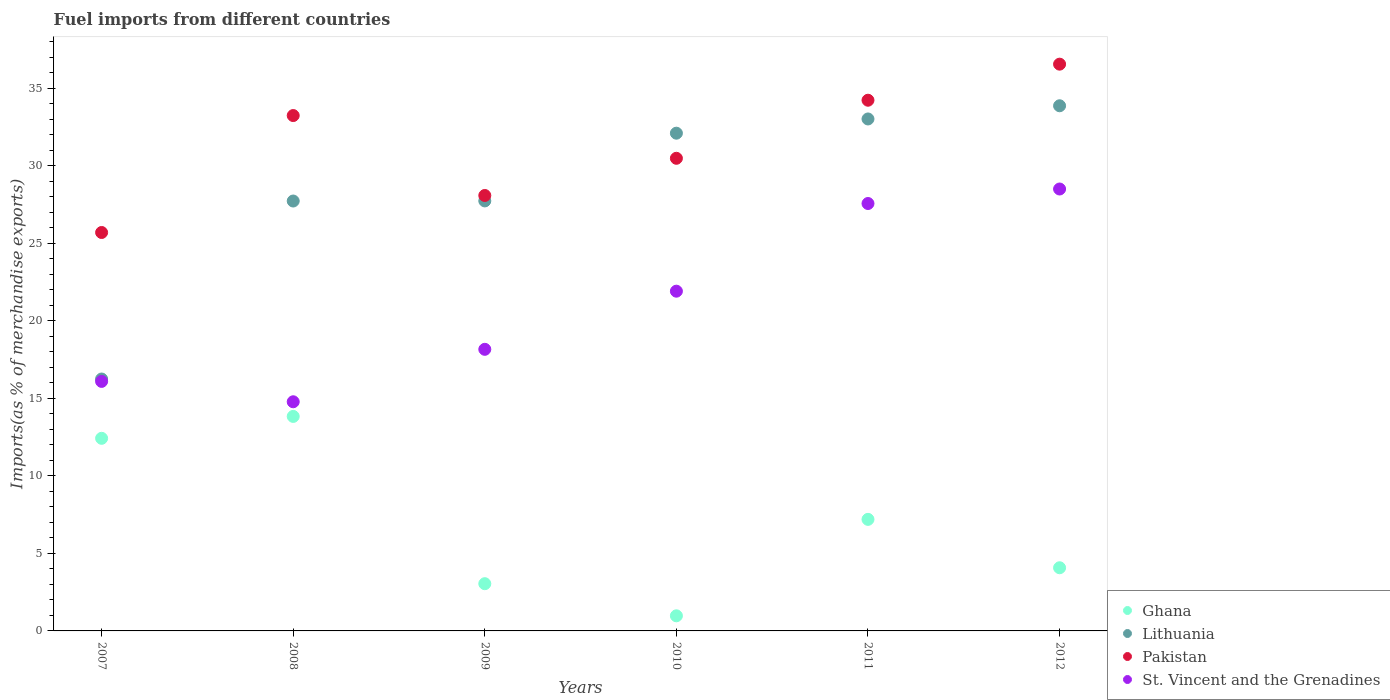How many different coloured dotlines are there?
Offer a very short reply. 4. What is the percentage of imports to different countries in St. Vincent and the Grenadines in 2011?
Provide a succinct answer. 27.57. Across all years, what is the maximum percentage of imports to different countries in Lithuania?
Give a very brief answer. 33.88. Across all years, what is the minimum percentage of imports to different countries in Pakistan?
Keep it short and to the point. 25.7. What is the total percentage of imports to different countries in Lithuania in the graph?
Ensure brevity in your answer.  170.74. What is the difference between the percentage of imports to different countries in St. Vincent and the Grenadines in 2009 and that in 2011?
Provide a succinct answer. -9.41. What is the difference between the percentage of imports to different countries in Pakistan in 2010 and the percentage of imports to different countries in Ghana in 2008?
Make the answer very short. 16.65. What is the average percentage of imports to different countries in Ghana per year?
Provide a short and direct response. 6.93. In the year 2012, what is the difference between the percentage of imports to different countries in Pakistan and percentage of imports to different countries in St. Vincent and the Grenadines?
Offer a very short reply. 8.05. What is the ratio of the percentage of imports to different countries in Ghana in 2009 to that in 2011?
Give a very brief answer. 0.42. Is the percentage of imports to different countries in Ghana in 2007 less than that in 2011?
Provide a succinct answer. No. Is the difference between the percentage of imports to different countries in Pakistan in 2008 and 2012 greater than the difference between the percentage of imports to different countries in St. Vincent and the Grenadines in 2008 and 2012?
Your response must be concise. Yes. What is the difference between the highest and the second highest percentage of imports to different countries in Lithuania?
Keep it short and to the point. 0.85. What is the difference between the highest and the lowest percentage of imports to different countries in Ghana?
Offer a terse response. 12.86. Is it the case that in every year, the sum of the percentage of imports to different countries in St. Vincent and the Grenadines and percentage of imports to different countries in Pakistan  is greater than the percentage of imports to different countries in Ghana?
Give a very brief answer. Yes. How many years are there in the graph?
Provide a short and direct response. 6. What is the difference between two consecutive major ticks on the Y-axis?
Offer a very short reply. 5. Are the values on the major ticks of Y-axis written in scientific E-notation?
Your response must be concise. No. Does the graph contain any zero values?
Your answer should be compact. No. Does the graph contain grids?
Make the answer very short. No. Where does the legend appear in the graph?
Your answer should be very brief. Bottom right. How are the legend labels stacked?
Give a very brief answer. Vertical. What is the title of the graph?
Keep it short and to the point. Fuel imports from different countries. What is the label or title of the Y-axis?
Ensure brevity in your answer.  Imports(as % of merchandise exports). What is the Imports(as % of merchandise exports) in Ghana in 2007?
Offer a very short reply. 12.43. What is the Imports(as % of merchandise exports) in Lithuania in 2007?
Give a very brief answer. 16.25. What is the Imports(as % of merchandise exports) in Pakistan in 2007?
Give a very brief answer. 25.7. What is the Imports(as % of merchandise exports) in St. Vincent and the Grenadines in 2007?
Make the answer very short. 16.1. What is the Imports(as % of merchandise exports) of Ghana in 2008?
Your response must be concise. 13.84. What is the Imports(as % of merchandise exports) in Lithuania in 2008?
Your answer should be very brief. 27.73. What is the Imports(as % of merchandise exports) in Pakistan in 2008?
Provide a short and direct response. 33.25. What is the Imports(as % of merchandise exports) of St. Vincent and the Grenadines in 2008?
Ensure brevity in your answer.  14.78. What is the Imports(as % of merchandise exports) in Ghana in 2009?
Offer a terse response. 3.05. What is the Imports(as % of merchandise exports) in Lithuania in 2009?
Ensure brevity in your answer.  27.74. What is the Imports(as % of merchandise exports) of Pakistan in 2009?
Make the answer very short. 28.09. What is the Imports(as % of merchandise exports) of St. Vincent and the Grenadines in 2009?
Give a very brief answer. 18.17. What is the Imports(as % of merchandise exports) in Ghana in 2010?
Keep it short and to the point. 0.97. What is the Imports(as % of merchandise exports) in Lithuania in 2010?
Keep it short and to the point. 32.11. What is the Imports(as % of merchandise exports) in Pakistan in 2010?
Give a very brief answer. 30.49. What is the Imports(as % of merchandise exports) of St. Vincent and the Grenadines in 2010?
Provide a short and direct response. 21.92. What is the Imports(as % of merchandise exports) of Ghana in 2011?
Make the answer very short. 7.2. What is the Imports(as % of merchandise exports) in Lithuania in 2011?
Provide a short and direct response. 33.03. What is the Imports(as % of merchandise exports) in Pakistan in 2011?
Provide a succinct answer. 34.24. What is the Imports(as % of merchandise exports) of St. Vincent and the Grenadines in 2011?
Your answer should be very brief. 27.57. What is the Imports(as % of merchandise exports) in Ghana in 2012?
Your response must be concise. 4.07. What is the Imports(as % of merchandise exports) in Lithuania in 2012?
Provide a succinct answer. 33.88. What is the Imports(as % of merchandise exports) in Pakistan in 2012?
Your answer should be compact. 36.56. What is the Imports(as % of merchandise exports) of St. Vincent and the Grenadines in 2012?
Your answer should be very brief. 28.51. Across all years, what is the maximum Imports(as % of merchandise exports) of Ghana?
Your answer should be compact. 13.84. Across all years, what is the maximum Imports(as % of merchandise exports) in Lithuania?
Keep it short and to the point. 33.88. Across all years, what is the maximum Imports(as % of merchandise exports) in Pakistan?
Offer a very short reply. 36.56. Across all years, what is the maximum Imports(as % of merchandise exports) of St. Vincent and the Grenadines?
Your answer should be compact. 28.51. Across all years, what is the minimum Imports(as % of merchandise exports) in Ghana?
Offer a terse response. 0.97. Across all years, what is the minimum Imports(as % of merchandise exports) in Lithuania?
Make the answer very short. 16.25. Across all years, what is the minimum Imports(as % of merchandise exports) of Pakistan?
Your response must be concise. 25.7. Across all years, what is the minimum Imports(as % of merchandise exports) in St. Vincent and the Grenadines?
Provide a short and direct response. 14.78. What is the total Imports(as % of merchandise exports) of Ghana in the graph?
Provide a succinct answer. 41.56. What is the total Imports(as % of merchandise exports) in Lithuania in the graph?
Ensure brevity in your answer.  170.74. What is the total Imports(as % of merchandise exports) of Pakistan in the graph?
Your answer should be compact. 188.33. What is the total Imports(as % of merchandise exports) in St. Vincent and the Grenadines in the graph?
Provide a succinct answer. 127.04. What is the difference between the Imports(as % of merchandise exports) of Ghana in 2007 and that in 2008?
Offer a terse response. -1.41. What is the difference between the Imports(as % of merchandise exports) of Lithuania in 2007 and that in 2008?
Make the answer very short. -11.48. What is the difference between the Imports(as % of merchandise exports) of Pakistan in 2007 and that in 2008?
Your response must be concise. -7.54. What is the difference between the Imports(as % of merchandise exports) of St. Vincent and the Grenadines in 2007 and that in 2008?
Provide a succinct answer. 1.31. What is the difference between the Imports(as % of merchandise exports) in Ghana in 2007 and that in 2009?
Give a very brief answer. 9.38. What is the difference between the Imports(as % of merchandise exports) in Lithuania in 2007 and that in 2009?
Keep it short and to the point. -11.49. What is the difference between the Imports(as % of merchandise exports) of Pakistan in 2007 and that in 2009?
Your answer should be very brief. -2.39. What is the difference between the Imports(as % of merchandise exports) in St. Vincent and the Grenadines in 2007 and that in 2009?
Offer a very short reply. -2.07. What is the difference between the Imports(as % of merchandise exports) in Ghana in 2007 and that in 2010?
Your answer should be very brief. 11.45. What is the difference between the Imports(as % of merchandise exports) in Lithuania in 2007 and that in 2010?
Provide a succinct answer. -15.86. What is the difference between the Imports(as % of merchandise exports) of Pakistan in 2007 and that in 2010?
Give a very brief answer. -4.79. What is the difference between the Imports(as % of merchandise exports) of St. Vincent and the Grenadines in 2007 and that in 2010?
Your answer should be compact. -5.82. What is the difference between the Imports(as % of merchandise exports) of Ghana in 2007 and that in 2011?
Keep it short and to the point. 5.23. What is the difference between the Imports(as % of merchandise exports) in Lithuania in 2007 and that in 2011?
Keep it short and to the point. -16.78. What is the difference between the Imports(as % of merchandise exports) in Pakistan in 2007 and that in 2011?
Give a very brief answer. -8.53. What is the difference between the Imports(as % of merchandise exports) in St. Vincent and the Grenadines in 2007 and that in 2011?
Offer a very short reply. -11.48. What is the difference between the Imports(as % of merchandise exports) of Ghana in 2007 and that in 2012?
Your answer should be compact. 8.35. What is the difference between the Imports(as % of merchandise exports) in Lithuania in 2007 and that in 2012?
Make the answer very short. -17.63. What is the difference between the Imports(as % of merchandise exports) of Pakistan in 2007 and that in 2012?
Make the answer very short. -10.86. What is the difference between the Imports(as % of merchandise exports) in St. Vincent and the Grenadines in 2007 and that in 2012?
Your answer should be compact. -12.41. What is the difference between the Imports(as % of merchandise exports) of Ghana in 2008 and that in 2009?
Provide a short and direct response. 10.79. What is the difference between the Imports(as % of merchandise exports) of Lithuania in 2008 and that in 2009?
Offer a very short reply. -0.01. What is the difference between the Imports(as % of merchandise exports) of Pakistan in 2008 and that in 2009?
Give a very brief answer. 5.16. What is the difference between the Imports(as % of merchandise exports) in St. Vincent and the Grenadines in 2008 and that in 2009?
Keep it short and to the point. -3.38. What is the difference between the Imports(as % of merchandise exports) of Ghana in 2008 and that in 2010?
Your response must be concise. 12.86. What is the difference between the Imports(as % of merchandise exports) of Lithuania in 2008 and that in 2010?
Give a very brief answer. -4.38. What is the difference between the Imports(as % of merchandise exports) in Pakistan in 2008 and that in 2010?
Provide a succinct answer. 2.76. What is the difference between the Imports(as % of merchandise exports) of St. Vincent and the Grenadines in 2008 and that in 2010?
Make the answer very short. -7.13. What is the difference between the Imports(as % of merchandise exports) in Ghana in 2008 and that in 2011?
Make the answer very short. 6.64. What is the difference between the Imports(as % of merchandise exports) of Lithuania in 2008 and that in 2011?
Your answer should be compact. -5.29. What is the difference between the Imports(as % of merchandise exports) in Pakistan in 2008 and that in 2011?
Your response must be concise. -0.99. What is the difference between the Imports(as % of merchandise exports) of St. Vincent and the Grenadines in 2008 and that in 2011?
Offer a terse response. -12.79. What is the difference between the Imports(as % of merchandise exports) of Ghana in 2008 and that in 2012?
Offer a very short reply. 9.76. What is the difference between the Imports(as % of merchandise exports) of Lithuania in 2008 and that in 2012?
Your answer should be compact. -6.14. What is the difference between the Imports(as % of merchandise exports) in Pakistan in 2008 and that in 2012?
Provide a succinct answer. -3.32. What is the difference between the Imports(as % of merchandise exports) in St. Vincent and the Grenadines in 2008 and that in 2012?
Your response must be concise. -13.73. What is the difference between the Imports(as % of merchandise exports) of Ghana in 2009 and that in 2010?
Provide a succinct answer. 2.07. What is the difference between the Imports(as % of merchandise exports) of Lithuania in 2009 and that in 2010?
Your answer should be compact. -4.37. What is the difference between the Imports(as % of merchandise exports) of Pakistan in 2009 and that in 2010?
Your answer should be very brief. -2.4. What is the difference between the Imports(as % of merchandise exports) of St. Vincent and the Grenadines in 2009 and that in 2010?
Give a very brief answer. -3.75. What is the difference between the Imports(as % of merchandise exports) in Ghana in 2009 and that in 2011?
Give a very brief answer. -4.15. What is the difference between the Imports(as % of merchandise exports) of Lithuania in 2009 and that in 2011?
Your answer should be very brief. -5.29. What is the difference between the Imports(as % of merchandise exports) in Pakistan in 2009 and that in 2011?
Provide a short and direct response. -6.15. What is the difference between the Imports(as % of merchandise exports) in St. Vincent and the Grenadines in 2009 and that in 2011?
Ensure brevity in your answer.  -9.41. What is the difference between the Imports(as % of merchandise exports) in Ghana in 2009 and that in 2012?
Offer a terse response. -1.03. What is the difference between the Imports(as % of merchandise exports) of Lithuania in 2009 and that in 2012?
Offer a very short reply. -6.14. What is the difference between the Imports(as % of merchandise exports) in Pakistan in 2009 and that in 2012?
Your answer should be compact. -8.47. What is the difference between the Imports(as % of merchandise exports) of St. Vincent and the Grenadines in 2009 and that in 2012?
Provide a short and direct response. -10.34. What is the difference between the Imports(as % of merchandise exports) in Ghana in 2010 and that in 2011?
Your answer should be compact. -6.22. What is the difference between the Imports(as % of merchandise exports) of Lithuania in 2010 and that in 2011?
Your response must be concise. -0.92. What is the difference between the Imports(as % of merchandise exports) in Pakistan in 2010 and that in 2011?
Provide a succinct answer. -3.75. What is the difference between the Imports(as % of merchandise exports) of St. Vincent and the Grenadines in 2010 and that in 2011?
Make the answer very short. -5.66. What is the difference between the Imports(as % of merchandise exports) of Ghana in 2010 and that in 2012?
Provide a short and direct response. -3.1. What is the difference between the Imports(as % of merchandise exports) in Lithuania in 2010 and that in 2012?
Offer a terse response. -1.77. What is the difference between the Imports(as % of merchandise exports) in Pakistan in 2010 and that in 2012?
Ensure brevity in your answer.  -6.07. What is the difference between the Imports(as % of merchandise exports) in St. Vincent and the Grenadines in 2010 and that in 2012?
Ensure brevity in your answer.  -6.59. What is the difference between the Imports(as % of merchandise exports) in Ghana in 2011 and that in 2012?
Offer a terse response. 3.12. What is the difference between the Imports(as % of merchandise exports) of Lithuania in 2011 and that in 2012?
Provide a succinct answer. -0.85. What is the difference between the Imports(as % of merchandise exports) of Pakistan in 2011 and that in 2012?
Offer a very short reply. -2.33. What is the difference between the Imports(as % of merchandise exports) of St. Vincent and the Grenadines in 2011 and that in 2012?
Your answer should be compact. -0.94. What is the difference between the Imports(as % of merchandise exports) in Ghana in 2007 and the Imports(as % of merchandise exports) in Lithuania in 2008?
Keep it short and to the point. -15.31. What is the difference between the Imports(as % of merchandise exports) in Ghana in 2007 and the Imports(as % of merchandise exports) in Pakistan in 2008?
Ensure brevity in your answer.  -20.82. What is the difference between the Imports(as % of merchandise exports) of Ghana in 2007 and the Imports(as % of merchandise exports) of St. Vincent and the Grenadines in 2008?
Your response must be concise. -2.36. What is the difference between the Imports(as % of merchandise exports) of Lithuania in 2007 and the Imports(as % of merchandise exports) of Pakistan in 2008?
Your response must be concise. -17. What is the difference between the Imports(as % of merchandise exports) in Lithuania in 2007 and the Imports(as % of merchandise exports) in St. Vincent and the Grenadines in 2008?
Ensure brevity in your answer.  1.47. What is the difference between the Imports(as % of merchandise exports) of Pakistan in 2007 and the Imports(as % of merchandise exports) of St. Vincent and the Grenadines in 2008?
Make the answer very short. 10.92. What is the difference between the Imports(as % of merchandise exports) of Ghana in 2007 and the Imports(as % of merchandise exports) of Lithuania in 2009?
Your answer should be compact. -15.32. What is the difference between the Imports(as % of merchandise exports) in Ghana in 2007 and the Imports(as % of merchandise exports) in Pakistan in 2009?
Your response must be concise. -15.67. What is the difference between the Imports(as % of merchandise exports) of Ghana in 2007 and the Imports(as % of merchandise exports) of St. Vincent and the Grenadines in 2009?
Make the answer very short. -5.74. What is the difference between the Imports(as % of merchandise exports) of Lithuania in 2007 and the Imports(as % of merchandise exports) of Pakistan in 2009?
Your response must be concise. -11.84. What is the difference between the Imports(as % of merchandise exports) of Lithuania in 2007 and the Imports(as % of merchandise exports) of St. Vincent and the Grenadines in 2009?
Your response must be concise. -1.92. What is the difference between the Imports(as % of merchandise exports) of Pakistan in 2007 and the Imports(as % of merchandise exports) of St. Vincent and the Grenadines in 2009?
Your answer should be compact. 7.54. What is the difference between the Imports(as % of merchandise exports) in Ghana in 2007 and the Imports(as % of merchandise exports) in Lithuania in 2010?
Your answer should be very brief. -19.68. What is the difference between the Imports(as % of merchandise exports) of Ghana in 2007 and the Imports(as % of merchandise exports) of Pakistan in 2010?
Your answer should be compact. -18.06. What is the difference between the Imports(as % of merchandise exports) in Ghana in 2007 and the Imports(as % of merchandise exports) in St. Vincent and the Grenadines in 2010?
Your answer should be very brief. -9.49. What is the difference between the Imports(as % of merchandise exports) in Lithuania in 2007 and the Imports(as % of merchandise exports) in Pakistan in 2010?
Make the answer very short. -14.24. What is the difference between the Imports(as % of merchandise exports) in Lithuania in 2007 and the Imports(as % of merchandise exports) in St. Vincent and the Grenadines in 2010?
Offer a very short reply. -5.67. What is the difference between the Imports(as % of merchandise exports) of Pakistan in 2007 and the Imports(as % of merchandise exports) of St. Vincent and the Grenadines in 2010?
Give a very brief answer. 3.79. What is the difference between the Imports(as % of merchandise exports) in Ghana in 2007 and the Imports(as % of merchandise exports) in Lithuania in 2011?
Your response must be concise. -20.6. What is the difference between the Imports(as % of merchandise exports) of Ghana in 2007 and the Imports(as % of merchandise exports) of Pakistan in 2011?
Offer a very short reply. -21.81. What is the difference between the Imports(as % of merchandise exports) in Ghana in 2007 and the Imports(as % of merchandise exports) in St. Vincent and the Grenadines in 2011?
Offer a very short reply. -15.15. What is the difference between the Imports(as % of merchandise exports) of Lithuania in 2007 and the Imports(as % of merchandise exports) of Pakistan in 2011?
Your answer should be very brief. -17.98. What is the difference between the Imports(as % of merchandise exports) of Lithuania in 2007 and the Imports(as % of merchandise exports) of St. Vincent and the Grenadines in 2011?
Your answer should be compact. -11.32. What is the difference between the Imports(as % of merchandise exports) in Pakistan in 2007 and the Imports(as % of merchandise exports) in St. Vincent and the Grenadines in 2011?
Ensure brevity in your answer.  -1.87. What is the difference between the Imports(as % of merchandise exports) of Ghana in 2007 and the Imports(as % of merchandise exports) of Lithuania in 2012?
Your answer should be compact. -21.45. What is the difference between the Imports(as % of merchandise exports) in Ghana in 2007 and the Imports(as % of merchandise exports) in Pakistan in 2012?
Ensure brevity in your answer.  -24.14. What is the difference between the Imports(as % of merchandise exports) in Ghana in 2007 and the Imports(as % of merchandise exports) in St. Vincent and the Grenadines in 2012?
Your response must be concise. -16.08. What is the difference between the Imports(as % of merchandise exports) in Lithuania in 2007 and the Imports(as % of merchandise exports) in Pakistan in 2012?
Give a very brief answer. -20.31. What is the difference between the Imports(as % of merchandise exports) in Lithuania in 2007 and the Imports(as % of merchandise exports) in St. Vincent and the Grenadines in 2012?
Your response must be concise. -12.26. What is the difference between the Imports(as % of merchandise exports) in Pakistan in 2007 and the Imports(as % of merchandise exports) in St. Vincent and the Grenadines in 2012?
Make the answer very short. -2.81. What is the difference between the Imports(as % of merchandise exports) in Ghana in 2008 and the Imports(as % of merchandise exports) in Lithuania in 2009?
Keep it short and to the point. -13.9. What is the difference between the Imports(as % of merchandise exports) in Ghana in 2008 and the Imports(as % of merchandise exports) in Pakistan in 2009?
Your response must be concise. -14.25. What is the difference between the Imports(as % of merchandise exports) of Ghana in 2008 and the Imports(as % of merchandise exports) of St. Vincent and the Grenadines in 2009?
Your answer should be compact. -4.33. What is the difference between the Imports(as % of merchandise exports) in Lithuania in 2008 and the Imports(as % of merchandise exports) in Pakistan in 2009?
Give a very brief answer. -0.36. What is the difference between the Imports(as % of merchandise exports) of Lithuania in 2008 and the Imports(as % of merchandise exports) of St. Vincent and the Grenadines in 2009?
Ensure brevity in your answer.  9.57. What is the difference between the Imports(as % of merchandise exports) in Pakistan in 2008 and the Imports(as % of merchandise exports) in St. Vincent and the Grenadines in 2009?
Offer a very short reply. 15.08. What is the difference between the Imports(as % of merchandise exports) in Ghana in 2008 and the Imports(as % of merchandise exports) in Lithuania in 2010?
Offer a terse response. -18.27. What is the difference between the Imports(as % of merchandise exports) of Ghana in 2008 and the Imports(as % of merchandise exports) of Pakistan in 2010?
Your answer should be very brief. -16.65. What is the difference between the Imports(as % of merchandise exports) in Ghana in 2008 and the Imports(as % of merchandise exports) in St. Vincent and the Grenadines in 2010?
Offer a terse response. -8.08. What is the difference between the Imports(as % of merchandise exports) in Lithuania in 2008 and the Imports(as % of merchandise exports) in Pakistan in 2010?
Provide a succinct answer. -2.76. What is the difference between the Imports(as % of merchandise exports) in Lithuania in 2008 and the Imports(as % of merchandise exports) in St. Vincent and the Grenadines in 2010?
Provide a short and direct response. 5.82. What is the difference between the Imports(as % of merchandise exports) in Pakistan in 2008 and the Imports(as % of merchandise exports) in St. Vincent and the Grenadines in 2010?
Ensure brevity in your answer.  11.33. What is the difference between the Imports(as % of merchandise exports) of Ghana in 2008 and the Imports(as % of merchandise exports) of Lithuania in 2011?
Your answer should be compact. -19.19. What is the difference between the Imports(as % of merchandise exports) of Ghana in 2008 and the Imports(as % of merchandise exports) of Pakistan in 2011?
Provide a short and direct response. -20.4. What is the difference between the Imports(as % of merchandise exports) in Ghana in 2008 and the Imports(as % of merchandise exports) in St. Vincent and the Grenadines in 2011?
Ensure brevity in your answer.  -13.73. What is the difference between the Imports(as % of merchandise exports) of Lithuania in 2008 and the Imports(as % of merchandise exports) of Pakistan in 2011?
Keep it short and to the point. -6.5. What is the difference between the Imports(as % of merchandise exports) in Lithuania in 2008 and the Imports(as % of merchandise exports) in St. Vincent and the Grenadines in 2011?
Offer a very short reply. 0.16. What is the difference between the Imports(as % of merchandise exports) in Pakistan in 2008 and the Imports(as % of merchandise exports) in St. Vincent and the Grenadines in 2011?
Your response must be concise. 5.67. What is the difference between the Imports(as % of merchandise exports) of Ghana in 2008 and the Imports(as % of merchandise exports) of Lithuania in 2012?
Your answer should be very brief. -20.04. What is the difference between the Imports(as % of merchandise exports) of Ghana in 2008 and the Imports(as % of merchandise exports) of Pakistan in 2012?
Give a very brief answer. -22.72. What is the difference between the Imports(as % of merchandise exports) in Ghana in 2008 and the Imports(as % of merchandise exports) in St. Vincent and the Grenadines in 2012?
Provide a succinct answer. -14.67. What is the difference between the Imports(as % of merchandise exports) in Lithuania in 2008 and the Imports(as % of merchandise exports) in Pakistan in 2012?
Your response must be concise. -8.83. What is the difference between the Imports(as % of merchandise exports) of Lithuania in 2008 and the Imports(as % of merchandise exports) of St. Vincent and the Grenadines in 2012?
Offer a terse response. -0.78. What is the difference between the Imports(as % of merchandise exports) in Pakistan in 2008 and the Imports(as % of merchandise exports) in St. Vincent and the Grenadines in 2012?
Keep it short and to the point. 4.74. What is the difference between the Imports(as % of merchandise exports) in Ghana in 2009 and the Imports(as % of merchandise exports) in Lithuania in 2010?
Offer a terse response. -29.06. What is the difference between the Imports(as % of merchandise exports) of Ghana in 2009 and the Imports(as % of merchandise exports) of Pakistan in 2010?
Offer a very short reply. -27.44. What is the difference between the Imports(as % of merchandise exports) in Ghana in 2009 and the Imports(as % of merchandise exports) in St. Vincent and the Grenadines in 2010?
Offer a very short reply. -18.87. What is the difference between the Imports(as % of merchandise exports) of Lithuania in 2009 and the Imports(as % of merchandise exports) of Pakistan in 2010?
Ensure brevity in your answer.  -2.75. What is the difference between the Imports(as % of merchandise exports) in Lithuania in 2009 and the Imports(as % of merchandise exports) in St. Vincent and the Grenadines in 2010?
Provide a succinct answer. 5.82. What is the difference between the Imports(as % of merchandise exports) of Pakistan in 2009 and the Imports(as % of merchandise exports) of St. Vincent and the Grenadines in 2010?
Make the answer very short. 6.17. What is the difference between the Imports(as % of merchandise exports) in Ghana in 2009 and the Imports(as % of merchandise exports) in Lithuania in 2011?
Give a very brief answer. -29.98. What is the difference between the Imports(as % of merchandise exports) of Ghana in 2009 and the Imports(as % of merchandise exports) of Pakistan in 2011?
Offer a terse response. -31.19. What is the difference between the Imports(as % of merchandise exports) in Ghana in 2009 and the Imports(as % of merchandise exports) in St. Vincent and the Grenadines in 2011?
Keep it short and to the point. -24.53. What is the difference between the Imports(as % of merchandise exports) of Lithuania in 2009 and the Imports(as % of merchandise exports) of Pakistan in 2011?
Offer a very short reply. -6.5. What is the difference between the Imports(as % of merchandise exports) in Lithuania in 2009 and the Imports(as % of merchandise exports) in St. Vincent and the Grenadines in 2011?
Make the answer very short. 0.17. What is the difference between the Imports(as % of merchandise exports) in Pakistan in 2009 and the Imports(as % of merchandise exports) in St. Vincent and the Grenadines in 2011?
Your response must be concise. 0.52. What is the difference between the Imports(as % of merchandise exports) in Ghana in 2009 and the Imports(as % of merchandise exports) in Lithuania in 2012?
Make the answer very short. -30.83. What is the difference between the Imports(as % of merchandise exports) of Ghana in 2009 and the Imports(as % of merchandise exports) of Pakistan in 2012?
Provide a succinct answer. -33.52. What is the difference between the Imports(as % of merchandise exports) in Ghana in 2009 and the Imports(as % of merchandise exports) in St. Vincent and the Grenadines in 2012?
Give a very brief answer. -25.46. What is the difference between the Imports(as % of merchandise exports) of Lithuania in 2009 and the Imports(as % of merchandise exports) of Pakistan in 2012?
Give a very brief answer. -8.82. What is the difference between the Imports(as % of merchandise exports) in Lithuania in 2009 and the Imports(as % of merchandise exports) in St. Vincent and the Grenadines in 2012?
Your answer should be very brief. -0.77. What is the difference between the Imports(as % of merchandise exports) of Pakistan in 2009 and the Imports(as % of merchandise exports) of St. Vincent and the Grenadines in 2012?
Your response must be concise. -0.42. What is the difference between the Imports(as % of merchandise exports) of Ghana in 2010 and the Imports(as % of merchandise exports) of Lithuania in 2011?
Offer a very short reply. -32.05. What is the difference between the Imports(as % of merchandise exports) of Ghana in 2010 and the Imports(as % of merchandise exports) of Pakistan in 2011?
Keep it short and to the point. -33.26. What is the difference between the Imports(as % of merchandise exports) of Ghana in 2010 and the Imports(as % of merchandise exports) of St. Vincent and the Grenadines in 2011?
Give a very brief answer. -26.6. What is the difference between the Imports(as % of merchandise exports) in Lithuania in 2010 and the Imports(as % of merchandise exports) in Pakistan in 2011?
Ensure brevity in your answer.  -2.13. What is the difference between the Imports(as % of merchandise exports) of Lithuania in 2010 and the Imports(as % of merchandise exports) of St. Vincent and the Grenadines in 2011?
Offer a very short reply. 4.54. What is the difference between the Imports(as % of merchandise exports) in Pakistan in 2010 and the Imports(as % of merchandise exports) in St. Vincent and the Grenadines in 2011?
Your answer should be compact. 2.92. What is the difference between the Imports(as % of merchandise exports) in Ghana in 2010 and the Imports(as % of merchandise exports) in Lithuania in 2012?
Offer a terse response. -32.9. What is the difference between the Imports(as % of merchandise exports) of Ghana in 2010 and the Imports(as % of merchandise exports) of Pakistan in 2012?
Your answer should be very brief. -35.59. What is the difference between the Imports(as % of merchandise exports) in Ghana in 2010 and the Imports(as % of merchandise exports) in St. Vincent and the Grenadines in 2012?
Offer a very short reply. -27.53. What is the difference between the Imports(as % of merchandise exports) in Lithuania in 2010 and the Imports(as % of merchandise exports) in Pakistan in 2012?
Offer a terse response. -4.45. What is the difference between the Imports(as % of merchandise exports) in Lithuania in 2010 and the Imports(as % of merchandise exports) in St. Vincent and the Grenadines in 2012?
Your answer should be compact. 3.6. What is the difference between the Imports(as % of merchandise exports) in Pakistan in 2010 and the Imports(as % of merchandise exports) in St. Vincent and the Grenadines in 2012?
Give a very brief answer. 1.98. What is the difference between the Imports(as % of merchandise exports) in Ghana in 2011 and the Imports(as % of merchandise exports) in Lithuania in 2012?
Offer a terse response. -26.68. What is the difference between the Imports(as % of merchandise exports) of Ghana in 2011 and the Imports(as % of merchandise exports) of Pakistan in 2012?
Your answer should be very brief. -29.37. What is the difference between the Imports(as % of merchandise exports) of Ghana in 2011 and the Imports(as % of merchandise exports) of St. Vincent and the Grenadines in 2012?
Offer a terse response. -21.31. What is the difference between the Imports(as % of merchandise exports) of Lithuania in 2011 and the Imports(as % of merchandise exports) of Pakistan in 2012?
Offer a very short reply. -3.54. What is the difference between the Imports(as % of merchandise exports) of Lithuania in 2011 and the Imports(as % of merchandise exports) of St. Vincent and the Grenadines in 2012?
Provide a succinct answer. 4.52. What is the difference between the Imports(as % of merchandise exports) of Pakistan in 2011 and the Imports(as % of merchandise exports) of St. Vincent and the Grenadines in 2012?
Offer a terse response. 5.73. What is the average Imports(as % of merchandise exports) in Ghana per year?
Offer a very short reply. 6.93. What is the average Imports(as % of merchandise exports) in Lithuania per year?
Ensure brevity in your answer.  28.46. What is the average Imports(as % of merchandise exports) in Pakistan per year?
Keep it short and to the point. 31.39. What is the average Imports(as % of merchandise exports) in St. Vincent and the Grenadines per year?
Keep it short and to the point. 21.17. In the year 2007, what is the difference between the Imports(as % of merchandise exports) in Ghana and Imports(as % of merchandise exports) in Lithuania?
Keep it short and to the point. -3.83. In the year 2007, what is the difference between the Imports(as % of merchandise exports) of Ghana and Imports(as % of merchandise exports) of Pakistan?
Keep it short and to the point. -13.28. In the year 2007, what is the difference between the Imports(as % of merchandise exports) of Ghana and Imports(as % of merchandise exports) of St. Vincent and the Grenadines?
Offer a terse response. -3.67. In the year 2007, what is the difference between the Imports(as % of merchandise exports) of Lithuania and Imports(as % of merchandise exports) of Pakistan?
Provide a short and direct response. -9.45. In the year 2007, what is the difference between the Imports(as % of merchandise exports) in Lithuania and Imports(as % of merchandise exports) in St. Vincent and the Grenadines?
Provide a succinct answer. 0.15. In the year 2007, what is the difference between the Imports(as % of merchandise exports) in Pakistan and Imports(as % of merchandise exports) in St. Vincent and the Grenadines?
Keep it short and to the point. 9.61. In the year 2008, what is the difference between the Imports(as % of merchandise exports) of Ghana and Imports(as % of merchandise exports) of Lithuania?
Make the answer very short. -13.9. In the year 2008, what is the difference between the Imports(as % of merchandise exports) of Ghana and Imports(as % of merchandise exports) of Pakistan?
Ensure brevity in your answer.  -19.41. In the year 2008, what is the difference between the Imports(as % of merchandise exports) of Ghana and Imports(as % of merchandise exports) of St. Vincent and the Grenadines?
Offer a very short reply. -0.95. In the year 2008, what is the difference between the Imports(as % of merchandise exports) in Lithuania and Imports(as % of merchandise exports) in Pakistan?
Provide a succinct answer. -5.51. In the year 2008, what is the difference between the Imports(as % of merchandise exports) in Lithuania and Imports(as % of merchandise exports) in St. Vincent and the Grenadines?
Give a very brief answer. 12.95. In the year 2008, what is the difference between the Imports(as % of merchandise exports) in Pakistan and Imports(as % of merchandise exports) in St. Vincent and the Grenadines?
Your response must be concise. 18.46. In the year 2009, what is the difference between the Imports(as % of merchandise exports) of Ghana and Imports(as % of merchandise exports) of Lithuania?
Your response must be concise. -24.69. In the year 2009, what is the difference between the Imports(as % of merchandise exports) in Ghana and Imports(as % of merchandise exports) in Pakistan?
Provide a short and direct response. -25.04. In the year 2009, what is the difference between the Imports(as % of merchandise exports) in Ghana and Imports(as % of merchandise exports) in St. Vincent and the Grenadines?
Offer a very short reply. -15.12. In the year 2009, what is the difference between the Imports(as % of merchandise exports) of Lithuania and Imports(as % of merchandise exports) of Pakistan?
Your answer should be very brief. -0.35. In the year 2009, what is the difference between the Imports(as % of merchandise exports) of Lithuania and Imports(as % of merchandise exports) of St. Vincent and the Grenadines?
Make the answer very short. 9.57. In the year 2009, what is the difference between the Imports(as % of merchandise exports) in Pakistan and Imports(as % of merchandise exports) in St. Vincent and the Grenadines?
Keep it short and to the point. 9.92. In the year 2010, what is the difference between the Imports(as % of merchandise exports) of Ghana and Imports(as % of merchandise exports) of Lithuania?
Provide a short and direct response. -31.13. In the year 2010, what is the difference between the Imports(as % of merchandise exports) of Ghana and Imports(as % of merchandise exports) of Pakistan?
Offer a very short reply. -29.52. In the year 2010, what is the difference between the Imports(as % of merchandise exports) of Ghana and Imports(as % of merchandise exports) of St. Vincent and the Grenadines?
Ensure brevity in your answer.  -20.94. In the year 2010, what is the difference between the Imports(as % of merchandise exports) of Lithuania and Imports(as % of merchandise exports) of Pakistan?
Provide a short and direct response. 1.62. In the year 2010, what is the difference between the Imports(as % of merchandise exports) of Lithuania and Imports(as % of merchandise exports) of St. Vincent and the Grenadines?
Your answer should be compact. 10.19. In the year 2010, what is the difference between the Imports(as % of merchandise exports) in Pakistan and Imports(as % of merchandise exports) in St. Vincent and the Grenadines?
Make the answer very short. 8.57. In the year 2011, what is the difference between the Imports(as % of merchandise exports) in Ghana and Imports(as % of merchandise exports) in Lithuania?
Keep it short and to the point. -25.83. In the year 2011, what is the difference between the Imports(as % of merchandise exports) of Ghana and Imports(as % of merchandise exports) of Pakistan?
Provide a short and direct response. -27.04. In the year 2011, what is the difference between the Imports(as % of merchandise exports) of Ghana and Imports(as % of merchandise exports) of St. Vincent and the Grenadines?
Provide a succinct answer. -20.38. In the year 2011, what is the difference between the Imports(as % of merchandise exports) of Lithuania and Imports(as % of merchandise exports) of Pakistan?
Provide a succinct answer. -1.21. In the year 2011, what is the difference between the Imports(as % of merchandise exports) of Lithuania and Imports(as % of merchandise exports) of St. Vincent and the Grenadines?
Provide a short and direct response. 5.45. In the year 2011, what is the difference between the Imports(as % of merchandise exports) of Pakistan and Imports(as % of merchandise exports) of St. Vincent and the Grenadines?
Your answer should be very brief. 6.66. In the year 2012, what is the difference between the Imports(as % of merchandise exports) of Ghana and Imports(as % of merchandise exports) of Lithuania?
Offer a terse response. -29.8. In the year 2012, what is the difference between the Imports(as % of merchandise exports) in Ghana and Imports(as % of merchandise exports) in Pakistan?
Offer a very short reply. -32.49. In the year 2012, what is the difference between the Imports(as % of merchandise exports) of Ghana and Imports(as % of merchandise exports) of St. Vincent and the Grenadines?
Make the answer very short. -24.43. In the year 2012, what is the difference between the Imports(as % of merchandise exports) in Lithuania and Imports(as % of merchandise exports) in Pakistan?
Your answer should be compact. -2.68. In the year 2012, what is the difference between the Imports(as % of merchandise exports) of Lithuania and Imports(as % of merchandise exports) of St. Vincent and the Grenadines?
Your answer should be compact. 5.37. In the year 2012, what is the difference between the Imports(as % of merchandise exports) in Pakistan and Imports(as % of merchandise exports) in St. Vincent and the Grenadines?
Keep it short and to the point. 8.05. What is the ratio of the Imports(as % of merchandise exports) of Ghana in 2007 to that in 2008?
Your answer should be very brief. 0.9. What is the ratio of the Imports(as % of merchandise exports) of Lithuania in 2007 to that in 2008?
Provide a succinct answer. 0.59. What is the ratio of the Imports(as % of merchandise exports) in Pakistan in 2007 to that in 2008?
Offer a very short reply. 0.77. What is the ratio of the Imports(as % of merchandise exports) of St. Vincent and the Grenadines in 2007 to that in 2008?
Your response must be concise. 1.09. What is the ratio of the Imports(as % of merchandise exports) of Ghana in 2007 to that in 2009?
Give a very brief answer. 4.08. What is the ratio of the Imports(as % of merchandise exports) in Lithuania in 2007 to that in 2009?
Offer a terse response. 0.59. What is the ratio of the Imports(as % of merchandise exports) of Pakistan in 2007 to that in 2009?
Your response must be concise. 0.92. What is the ratio of the Imports(as % of merchandise exports) of St. Vincent and the Grenadines in 2007 to that in 2009?
Ensure brevity in your answer.  0.89. What is the ratio of the Imports(as % of merchandise exports) of Ghana in 2007 to that in 2010?
Offer a very short reply. 12.75. What is the ratio of the Imports(as % of merchandise exports) in Lithuania in 2007 to that in 2010?
Offer a terse response. 0.51. What is the ratio of the Imports(as % of merchandise exports) in Pakistan in 2007 to that in 2010?
Keep it short and to the point. 0.84. What is the ratio of the Imports(as % of merchandise exports) in St. Vincent and the Grenadines in 2007 to that in 2010?
Your response must be concise. 0.73. What is the ratio of the Imports(as % of merchandise exports) of Ghana in 2007 to that in 2011?
Your answer should be very brief. 1.73. What is the ratio of the Imports(as % of merchandise exports) in Lithuania in 2007 to that in 2011?
Make the answer very short. 0.49. What is the ratio of the Imports(as % of merchandise exports) of Pakistan in 2007 to that in 2011?
Ensure brevity in your answer.  0.75. What is the ratio of the Imports(as % of merchandise exports) of St. Vincent and the Grenadines in 2007 to that in 2011?
Your response must be concise. 0.58. What is the ratio of the Imports(as % of merchandise exports) in Ghana in 2007 to that in 2012?
Give a very brief answer. 3.05. What is the ratio of the Imports(as % of merchandise exports) of Lithuania in 2007 to that in 2012?
Your answer should be very brief. 0.48. What is the ratio of the Imports(as % of merchandise exports) of Pakistan in 2007 to that in 2012?
Provide a succinct answer. 0.7. What is the ratio of the Imports(as % of merchandise exports) in St. Vincent and the Grenadines in 2007 to that in 2012?
Your response must be concise. 0.56. What is the ratio of the Imports(as % of merchandise exports) of Ghana in 2008 to that in 2009?
Give a very brief answer. 4.54. What is the ratio of the Imports(as % of merchandise exports) of Pakistan in 2008 to that in 2009?
Ensure brevity in your answer.  1.18. What is the ratio of the Imports(as % of merchandise exports) of St. Vincent and the Grenadines in 2008 to that in 2009?
Keep it short and to the point. 0.81. What is the ratio of the Imports(as % of merchandise exports) in Ghana in 2008 to that in 2010?
Offer a very short reply. 14.2. What is the ratio of the Imports(as % of merchandise exports) of Lithuania in 2008 to that in 2010?
Make the answer very short. 0.86. What is the ratio of the Imports(as % of merchandise exports) in Pakistan in 2008 to that in 2010?
Ensure brevity in your answer.  1.09. What is the ratio of the Imports(as % of merchandise exports) of St. Vincent and the Grenadines in 2008 to that in 2010?
Give a very brief answer. 0.67. What is the ratio of the Imports(as % of merchandise exports) in Ghana in 2008 to that in 2011?
Your answer should be compact. 1.92. What is the ratio of the Imports(as % of merchandise exports) of Lithuania in 2008 to that in 2011?
Give a very brief answer. 0.84. What is the ratio of the Imports(as % of merchandise exports) of Pakistan in 2008 to that in 2011?
Keep it short and to the point. 0.97. What is the ratio of the Imports(as % of merchandise exports) of St. Vincent and the Grenadines in 2008 to that in 2011?
Your answer should be compact. 0.54. What is the ratio of the Imports(as % of merchandise exports) in Ghana in 2008 to that in 2012?
Offer a terse response. 3.4. What is the ratio of the Imports(as % of merchandise exports) of Lithuania in 2008 to that in 2012?
Offer a very short reply. 0.82. What is the ratio of the Imports(as % of merchandise exports) of Pakistan in 2008 to that in 2012?
Your answer should be very brief. 0.91. What is the ratio of the Imports(as % of merchandise exports) in St. Vincent and the Grenadines in 2008 to that in 2012?
Give a very brief answer. 0.52. What is the ratio of the Imports(as % of merchandise exports) of Ghana in 2009 to that in 2010?
Offer a very short reply. 3.13. What is the ratio of the Imports(as % of merchandise exports) in Lithuania in 2009 to that in 2010?
Your answer should be compact. 0.86. What is the ratio of the Imports(as % of merchandise exports) in Pakistan in 2009 to that in 2010?
Your response must be concise. 0.92. What is the ratio of the Imports(as % of merchandise exports) in St. Vincent and the Grenadines in 2009 to that in 2010?
Provide a short and direct response. 0.83. What is the ratio of the Imports(as % of merchandise exports) in Ghana in 2009 to that in 2011?
Provide a succinct answer. 0.42. What is the ratio of the Imports(as % of merchandise exports) in Lithuania in 2009 to that in 2011?
Offer a very short reply. 0.84. What is the ratio of the Imports(as % of merchandise exports) of Pakistan in 2009 to that in 2011?
Offer a terse response. 0.82. What is the ratio of the Imports(as % of merchandise exports) of St. Vincent and the Grenadines in 2009 to that in 2011?
Offer a terse response. 0.66. What is the ratio of the Imports(as % of merchandise exports) of Ghana in 2009 to that in 2012?
Keep it short and to the point. 0.75. What is the ratio of the Imports(as % of merchandise exports) of Lithuania in 2009 to that in 2012?
Give a very brief answer. 0.82. What is the ratio of the Imports(as % of merchandise exports) in Pakistan in 2009 to that in 2012?
Provide a succinct answer. 0.77. What is the ratio of the Imports(as % of merchandise exports) in St. Vincent and the Grenadines in 2009 to that in 2012?
Your answer should be compact. 0.64. What is the ratio of the Imports(as % of merchandise exports) in Ghana in 2010 to that in 2011?
Give a very brief answer. 0.14. What is the ratio of the Imports(as % of merchandise exports) of Lithuania in 2010 to that in 2011?
Give a very brief answer. 0.97. What is the ratio of the Imports(as % of merchandise exports) in Pakistan in 2010 to that in 2011?
Make the answer very short. 0.89. What is the ratio of the Imports(as % of merchandise exports) in St. Vincent and the Grenadines in 2010 to that in 2011?
Your response must be concise. 0.79. What is the ratio of the Imports(as % of merchandise exports) of Ghana in 2010 to that in 2012?
Provide a short and direct response. 0.24. What is the ratio of the Imports(as % of merchandise exports) of Lithuania in 2010 to that in 2012?
Give a very brief answer. 0.95. What is the ratio of the Imports(as % of merchandise exports) in Pakistan in 2010 to that in 2012?
Provide a short and direct response. 0.83. What is the ratio of the Imports(as % of merchandise exports) in St. Vincent and the Grenadines in 2010 to that in 2012?
Your answer should be compact. 0.77. What is the ratio of the Imports(as % of merchandise exports) in Ghana in 2011 to that in 2012?
Keep it short and to the point. 1.77. What is the ratio of the Imports(as % of merchandise exports) of Lithuania in 2011 to that in 2012?
Your answer should be very brief. 0.97. What is the ratio of the Imports(as % of merchandise exports) in Pakistan in 2011 to that in 2012?
Provide a short and direct response. 0.94. What is the ratio of the Imports(as % of merchandise exports) in St. Vincent and the Grenadines in 2011 to that in 2012?
Make the answer very short. 0.97. What is the difference between the highest and the second highest Imports(as % of merchandise exports) in Ghana?
Ensure brevity in your answer.  1.41. What is the difference between the highest and the second highest Imports(as % of merchandise exports) in Lithuania?
Provide a short and direct response. 0.85. What is the difference between the highest and the second highest Imports(as % of merchandise exports) in Pakistan?
Offer a terse response. 2.33. What is the difference between the highest and the second highest Imports(as % of merchandise exports) in St. Vincent and the Grenadines?
Keep it short and to the point. 0.94. What is the difference between the highest and the lowest Imports(as % of merchandise exports) in Ghana?
Your answer should be very brief. 12.86. What is the difference between the highest and the lowest Imports(as % of merchandise exports) in Lithuania?
Ensure brevity in your answer.  17.63. What is the difference between the highest and the lowest Imports(as % of merchandise exports) in Pakistan?
Keep it short and to the point. 10.86. What is the difference between the highest and the lowest Imports(as % of merchandise exports) of St. Vincent and the Grenadines?
Offer a terse response. 13.73. 